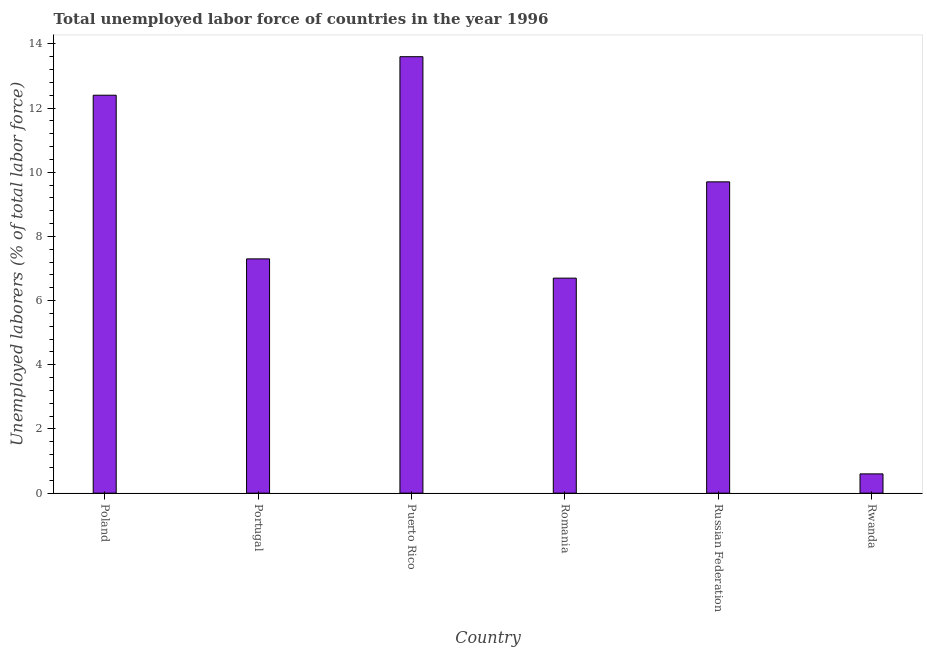Does the graph contain any zero values?
Offer a very short reply. No. What is the title of the graph?
Make the answer very short. Total unemployed labor force of countries in the year 1996. What is the label or title of the Y-axis?
Your answer should be very brief. Unemployed laborers (% of total labor force). What is the total unemployed labour force in Rwanda?
Offer a terse response. 0.6. Across all countries, what is the maximum total unemployed labour force?
Offer a terse response. 13.6. Across all countries, what is the minimum total unemployed labour force?
Offer a terse response. 0.6. In which country was the total unemployed labour force maximum?
Provide a short and direct response. Puerto Rico. In which country was the total unemployed labour force minimum?
Make the answer very short. Rwanda. What is the sum of the total unemployed labour force?
Offer a very short reply. 50.3. What is the average total unemployed labour force per country?
Your answer should be compact. 8.38. In how many countries, is the total unemployed labour force greater than 13.6 %?
Offer a very short reply. 1. What is the ratio of the total unemployed labour force in Romania to that in Rwanda?
Offer a very short reply. 11.17. Is the difference between the total unemployed labour force in Portugal and Puerto Rico greater than the difference between any two countries?
Offer a terse response. No. What is the difference between the highest and the lowest total unemployed labour force?
Give a very brief answer. 13. How many bars are there?
Your answer should be compact. 6. Are all the bars in the graph horizontal?
Keep it short and to the point. No. What is the Unemployed laborers (% of total labor force) of Poland?
Your answer should be compact. 12.4. What is the Unemployed laborers (% of total labor force) of Portugal?
Make the answer very short. 7.3. What is the Unemployed laborers (% of total labor force) of Puerto Rico?
Provide a short and direct response. 13.6. What is the Unemployed laborers (% of total labor force) of Romania?
Give a very brief answer. 6.7. What is the Unemployed laborers (% of total labor force) of Russian Federation?
Make the answer very short. 9.7. What is the Unemployed laborers (% of total labor force) in Rwanda?
Your answer should be very brief. 0.6. What is the difference between the Unemployed laborers (% of total labor force) in Poland and Portugal?
Offer a terse response. 5.1. What is the difference between the Unemployed laborers (% of total labor force) in Poland and Romania?
Ensure brevity in your answer.  5.7. What is the difference between the Unemployed laborers (% of total labor force) in Poland and Rwanda?
Provide a succinct answer. 11.8. What is the difference between the Unemployed laborers (% of total labor force) in Portugal and Puerto Rico?
Keep it short and to the point. -6.3. What is the difference between the Unemployed laborers (% of total labor force) in Portugal and Rwanda?
Give a very brief answer. 6.7. What is the difference between the Unemployed laborers (% of total labor force) in Puerto Rico and Romania?
Keep it short and to the point. 6.9. What is the difference between the Unemployed laborers (% of total labor force) in Romania and Russian Federation?
Offer a terse response. -3. What is the difference between the Unemployed laborers (% of total labor force) in Romania and Rwanda?
Provide a short and direct response. 6.1. What is the ratio of the Unemployed laborers (% of total labor force) in Poland to that in Portugal?
Your answer should be compact. 1.7. What is the ratio of the Unemployed laborers (% of total labor force) in Poland to that in Puerto Rico?
Ensure brevity in your answer.  0.91. What is the ratio of the Unemployed laborers (% of total labor force) in Poland to that in Romania?
Ensure brevity in your answer.  1.85. What is the ratio of the Unemployed laborers (% of total labor force) in Poland to that in Russian Federation?
Your response must be concise. 1.28. What is the ratio of the Unemployed laborers (% of total labor force) in Poland to that in Rwanda?
Make the answer very short. 20.67. What is the ratio of the Unemployed laborers (% of total labor force) in Portugal to that in Puerto Rico?
Give a very brief answer. 0.54. What is the ratio of the Unemployed laborers (% of total labor force) in Portugal to that in Romania?
Offer a very short reply. 1.09. What is the ratio of the Unemployed laborers (% of total labor force) in Portugal to that in Russian Federation?
Your response must be concise. 0.75. What is the ratio of the Unemployed laborers (% of total labor force) in Portugal to that in Rwanda?
Your answer should be very brief. 12.17. What is the ratio of the Unemployed laborers (% of total labor force) in Puerto Rico to that in Romania?
Offer a very short reply. 2.03. What is the ratio of the Unemployed laborers (% of total labor force) in Puerto Rico to that in Russian Federation?
Make the answer very short. 1.4. What is the ratio of the Unemployed laborers (% of total labor force) in Puerto Rico to that in Rwanda?
Ensure brevity in your answer.  22.67. What is the ratio of the Unemployed laborers (% of total labor force) in Romania to that in Russian Federation?
Your answer should be compact. 0.69. What is the ratio of the Unemployed laborers (% of total labor force) in Romania to that in Rwanda?
Give a very brief answer. 11.17. What is the ratio of the Unemployed laborers (% of total labor force) in Russian Federation to that in Rwanda?
Ensure brevity in your answer.  16.17. 